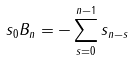<formula> <loc_0><loc_0><loc_500><loc_500>s _ { 0 } B _ { n } = - \sum _ { s = 0 } ^ { n - 1 } s _ { n - s }</formula> 